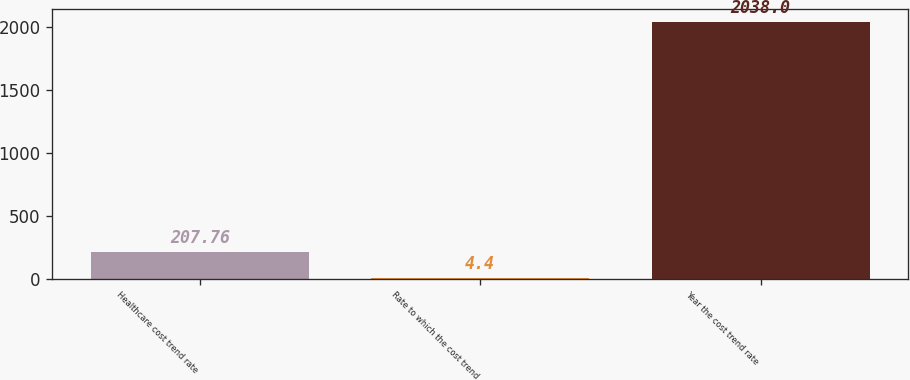<chart> <loc_0><loc_0><loc_500><loc_500><bar_chart><fcel>Healthcare cost trend rate<fcel>Rate to which the cost trend<fcel>Year the cost trend rate<nl><fcel>207.76<fcel>4.4<fcel>2038<nl></chart> 